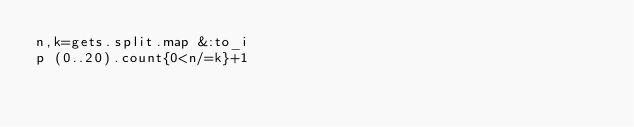<code> <loc_0><loc_0><loc_500><loc_500><_Ruby_>n,k=gets.split.map &:to_i
p (0..20).count{0<n/=k}+1</code> 